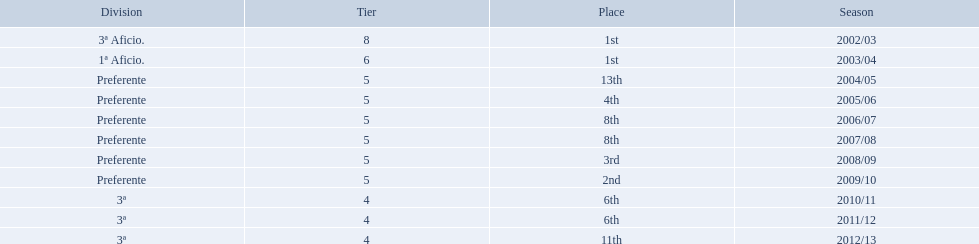Which seasons were played in tier four? 2010/11, 2011/12, 2012/13. Of these seasons, which resulted in 6th place? 2010/11, 2011/12. Which of the remaining happened last? 2011/12. 